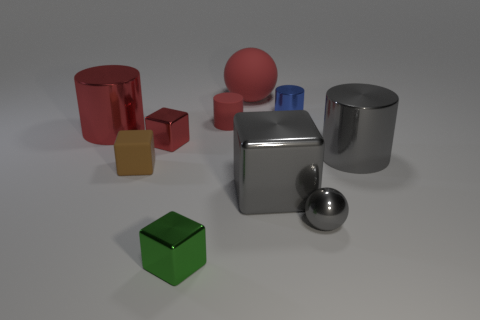Subtract all cylinders. How many objects are left? 6 Add 2 tiny green metallic things. How many tiny green metallic things are left? 3 Add 5 brown matte cubes. How many brown matte cubes exist? 6 Subtract 0 purple balls. How many objects are left? 10 Subtract all large red spheres. Subtract all big red objects. How many objects are left? 7 